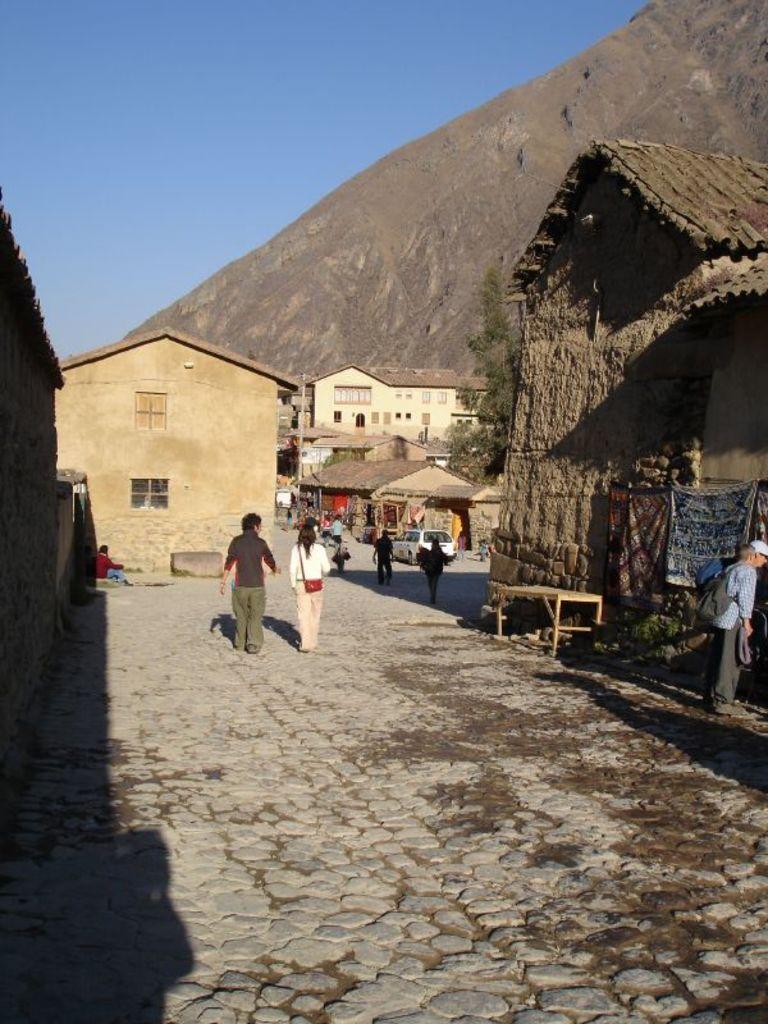In one or two sentences, can you explain what this image depicts? In this picture we can observe some people walking. There are some houses. There is a bench on the right side. In the background there is a hill and sky. 